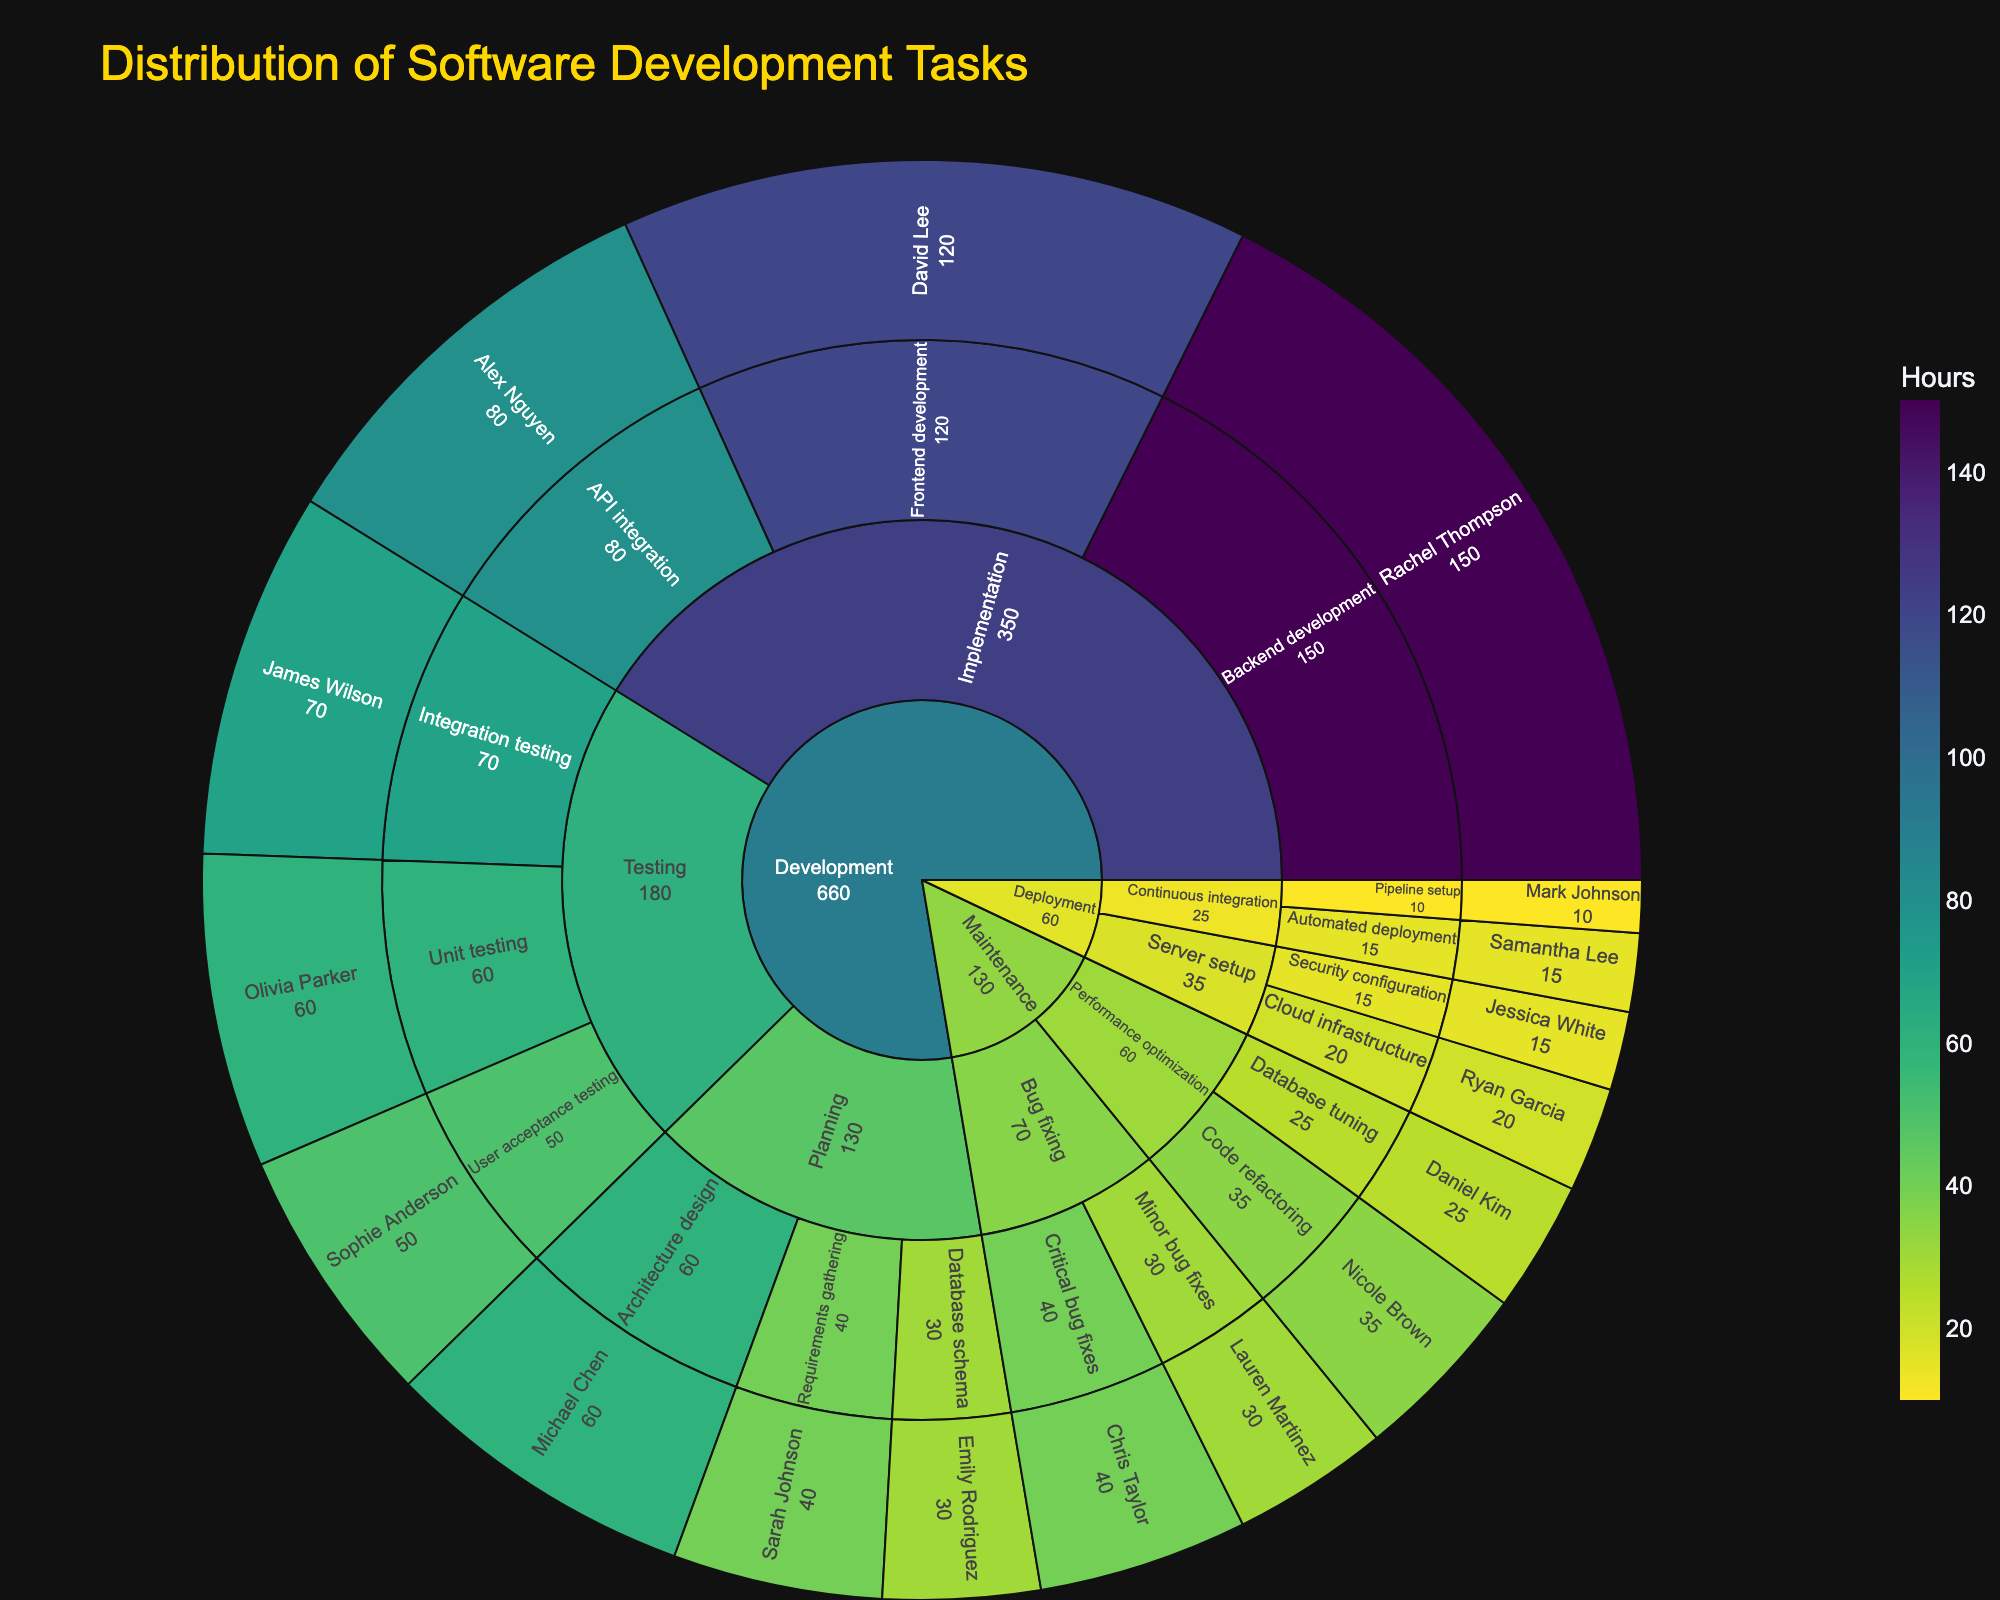What is the title of the sunburst plot? The title of a sunburst plot is typically located at the top and provides a summary of the plot's content. In this case, it mentions the primary focus of the plot.
Answer: Distribution of Software Development Tasks Which phase has the highest number of hours? Observing the sunburst plot, the size of each segment represents the number of hours. The larger the segment, the more hours are allocated to that phase. Compare the segments at the phase level.
Answer: Implementation How many hours did Michael Chen spend on tasks? Look for the segment labeled "Michael Chen" within the plot. The number of hours is often indicated alongside or within the segment.
Answer: 60 Which team member worked on Frontend development? Trace the path (project -> phase -> task) to find the "Frontend development" segment and identify the team member associated with that segment.
Answer: David Lee What is the total number of hours spent on Testing phase? Sum the hours from all tasks under the Testing phase (Unit testing, Integration testing, User acceptance testing).
Answer: 180 Who spent more hours, Sophie Anderson or Samantha Lee? Compare the hours associated with "Sophie Anderson" and "Samantha Lee." Check their corresponding segments for the hours.
Answer: Sophie Anderson Which task under Maintenance has the least hours? Within the Maintenance phase, compare the segments for each task (Critical bug fixes, Minor bug fixes, Database tuning, Code refactoring) and identify the one with the smallest value.
Answer: Database tuning What is the sum of hours spent on Development phase? Sum the hours spent on all tasks under the Development phase (Planning, Implementation, Testing).
Answer: 660 How many hours are dedicated to Deployment phase? Sum the hours from all tasks under the Deployment phase (Cloud infrastructure, Security configuration, Pipeline setup, Automated deployment).
Answer: 60 Who handled Automated deployment, and how many hours did it take? Find the "Automated deployment" segment in the plot and note the associated team member and hours from the segment label.
Answer: Samantha Lee, 15 